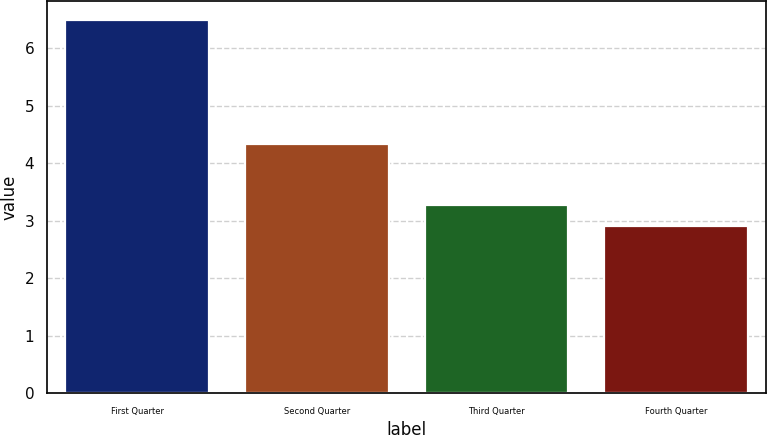Convert chart. <chart><loc_0><loc_0><loc_500><loc_500><bar_chart><fcel>First Quarter<fcel>Second Quarter<fcel>Third Quarter<fcel>Fourth Quarter<nl><fcel>6.5<fcel>4.34<fcel>3.27<fcel>2.91<nl></chart> 